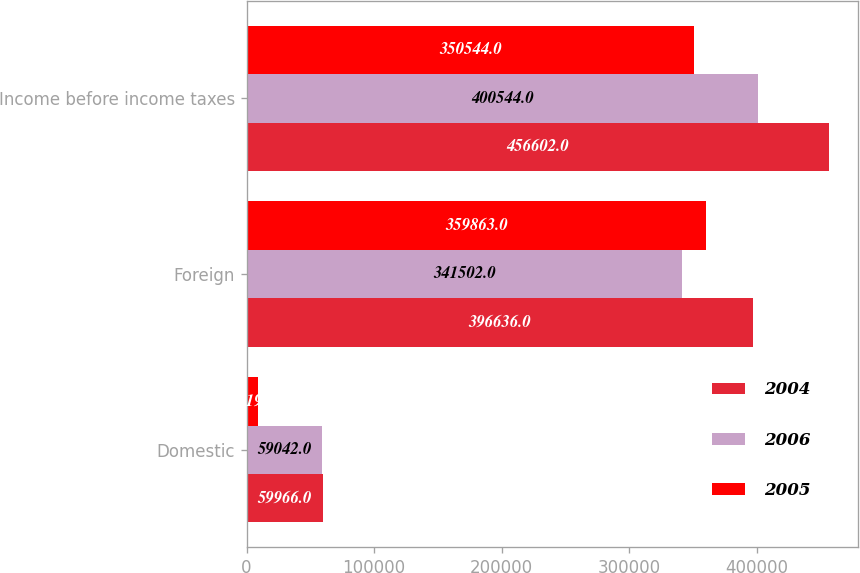Convert chart. <chart><loc_0><loc_0><loc_500><loc_500><stacked_bar_chart><ecel><fcel>Domestic<fcel>Foreign<fcel>Income before income taxes<nl><fcel>2004<fcel>59966<fcel>396636<fcel>456602<nl><fcel>2006<fcel>59042<fcel>341502<fcel>400544<nl><fcel>2005<fcel>9319<fcel>359863<fcel>350544<nl></chart> 